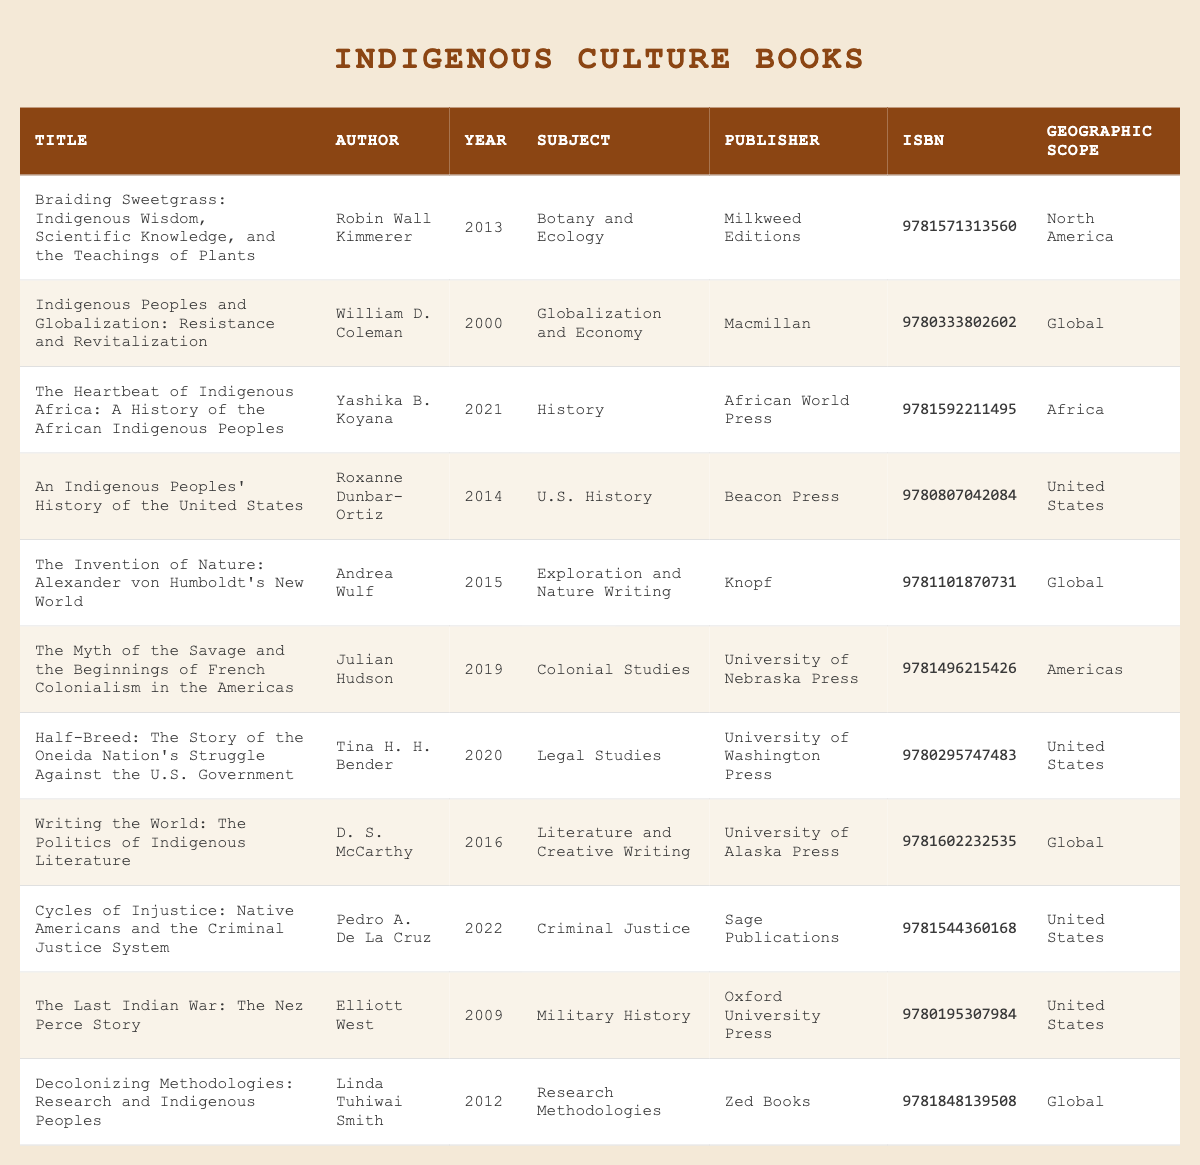What is the title of the book authored by Robin Wall Kimmerer? The table lists Robin Wall Kimmerer as the author of "Braiding Sweetgrass: Indigenous Wisdom, Scientific Knowledge, and the Teachings of Plants." The title is clearly stated in the first column of the table.
Answer: Braiding Sweetgrass: Indigenous Wisdom, Scientific Knowledge, and the Teachings of Plants Which book was published in 2012? The table indicates that "Decolonizing Methodologies: Research and Indigenous Peoples" was published in 2012, as seen in the "Publication Year" column corresponding to that title.
Answer: Decolonizing Methodologies: Research and Indigenous Peoples How many books in the table focus on U.S. history? There are two titles that focus specifically on U.S. history: "An Indigenous Peoples' History of the United States" and "Half-Breed: The Story of the Oneida Nation's Struggle Against the U.S. Government." Both books are listed under the "Subject" column related to U.S. History.
Answer: 2 Is "The Invention of Nature" focused on exploration and nature writing? Yes, the table categorizes "The Invention of Nature: Alexander von Humboldt's New World" under the "Exploration and Nature Writing" subject, confirming it fits that focus.
Answer: Yes What is the geographic scope of books authored by D. S. McCarthy? D. S. McCarthy's book "Writing the World: The Politics of Indigenous Literature" is classified under "Global" in the "Geographic Scope" column, indicating its coverage is extensive.
Answer: Global List the subjects of books published after 2015. From the table, the books published after 2015 are "The Heartbeat of Indigenous Africa" (History), "Half-Breed" (Legal Studies), "Writing the World" (Literature and Creative Writing), "Cycles of Injustice" (Criminal Justice), and "Decolonizing Methodologies" (Research Methodologies). This list includes their respective subjects.
Answer: History, Legal Studies, Literature and Creative Writing, Criminal Justice, Research Methodologies What is the average publication year of the books focusing on Criminal Justice? There is one book listed under Criminal Justice: "Cycles of Injustice: Native Americans and the Criminal Justice System" published in 2022. Since there’s only one book, the average publication year is simply 2022.
Answer: 2022 Are there any books that cover Global subjects published before 2010? No, the table shows that the earliest publication of Global subjects is "Indigenous Peoples and Globalization: Resistance and Revitalization," published in 2000. Checking the column confirms this as well.
Answer: No Which author has a book published in 2021, and what is the subject? The author Yashika B. Koyana published "The Heartbeat of Indigenous Africa: A History of the African Indigenous Peoples" in 2021. The subject is categorized as "History" in the table.
Answer: Yashika B. Koyana, History How many publishers are listed for books on Indigenous cultures? The unique publishers listed in the table are: Milkweed Editions, Macmillan, African World Press, Beacon Press, Knopf, University of Nebraska Press, University of Washington Press, University of Alaska Press, Sage Publications, and Zed Books, totaling 10 different publishers.
Answer: 10 